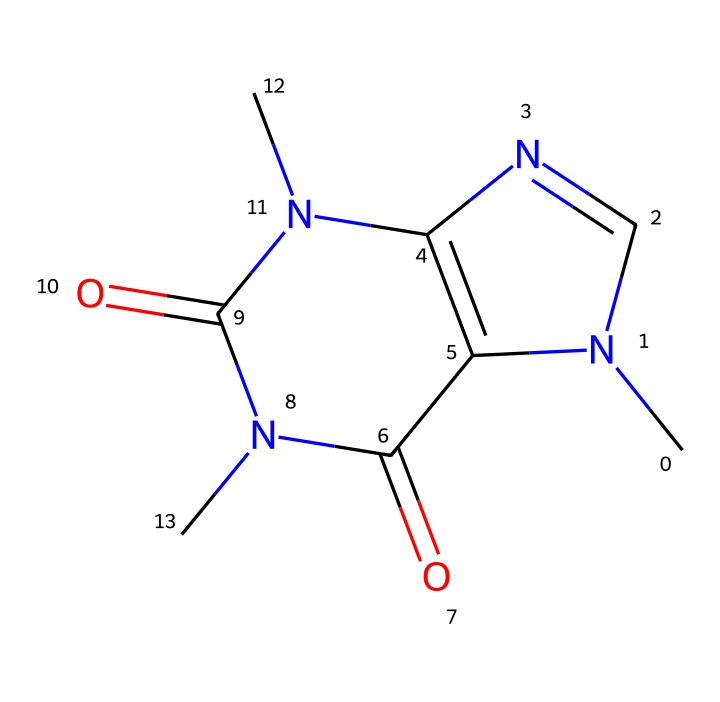What is the molecular formula of this chemical? To determine the molecular formula from the given SMILES, we can count the different atoms present. The SMILES representation indicates the presence of carbon (C), hydrogen (H), nitrogen (N), and oxygen (O) atoms. By analyzing the structure, we see that there are 8 carbons, 10 hydrogens, 4 nitrogens, and 2 oxygens. Therefore, the molecular formula is C8H10N4O2.
Answer: C8H10N4O2 How many rings are present in this structure? To identify the number of rings, we examine the connectivity of the atoms in the SMILES. The notation includes numbers that indicate cyclic structures. In this compound, there are two rings formed by the combining points indicated by the numbers. Thus, there are two distinct rings in the caffeine structure.
Answer: 2 Which element is represented most frequently in this chemical? By counting the numbers of each type of atom from the molecular formula, we note there are 8 carbon atoms, 10 hydrogen atoms, 4 nitrogen atoms, and 2 oxygen atoms. Since hydrogen has the highest count in this structure at 10, it is the most frequent element.
Answer: hydrogen What class of compounds does this molecule belong to? Caffeine is classified as an alkaloid, which is a group of naturally occurring organic compounds that mainly contain nitrogen. The presence of multiple nitrogen atoms in the structure indicates that it falls within this class.
Answer: alkaloid What is the significance of the nitrogen atoms in this structure? The nitrogen atoms are crucial because they contribute to the basic properties of caffeine, including its stimulant effects. The presence of nitrogen also suggests it's an alkaloid, which often affects neurotransmitter function in the brain. Thus, they play a vital role in the bioactivity of caffeine.
Answer: stimulant effects Which part of this structure contributes to its solubility in water? The presence of nitrogen and oxygen heteroatoms, particularly the polar functional groups associated with them, enhances solubility in water through hydrogen bonding. This polar nature increases interactions with water molecules, aiding in its dissolution.
Answer: polar functional groups 